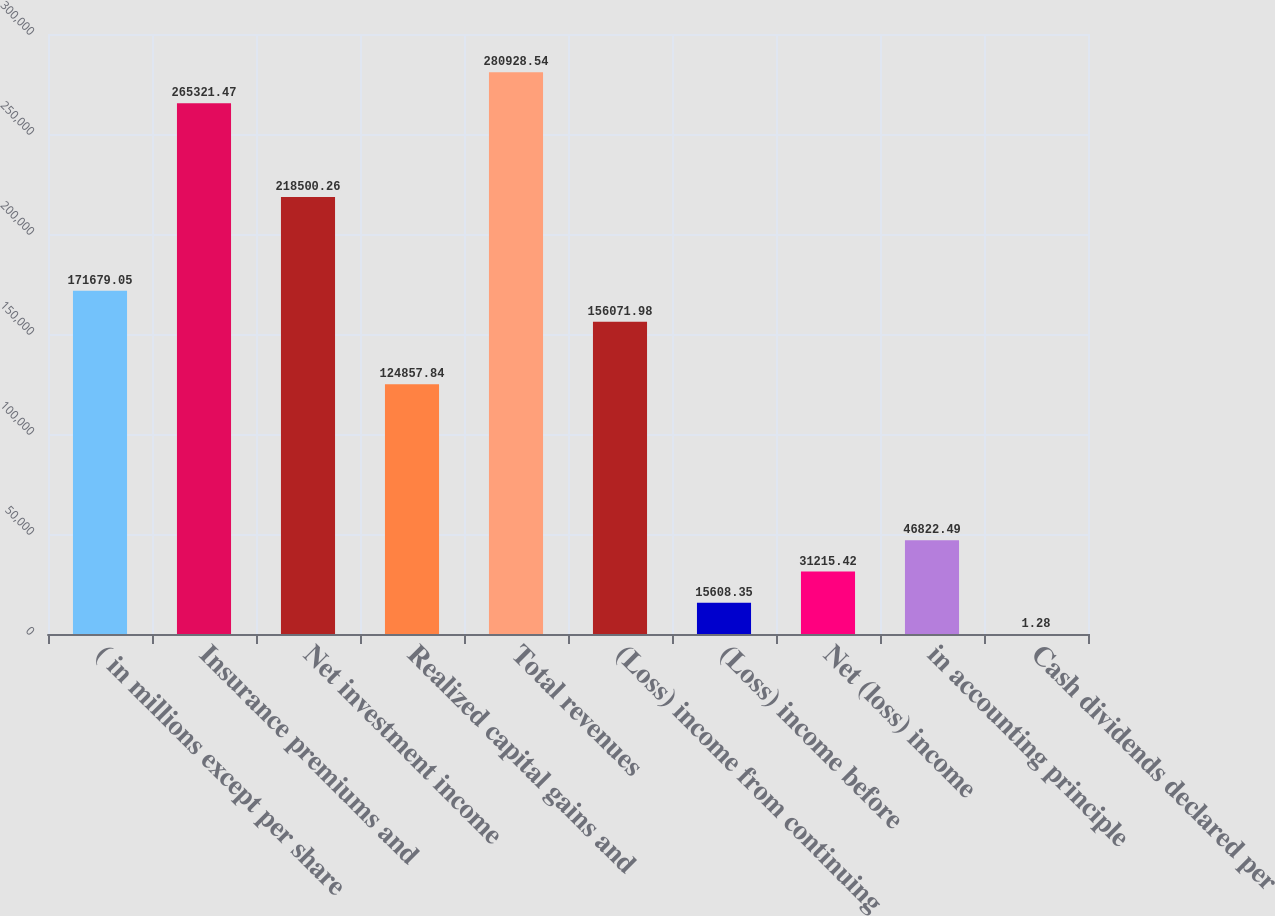Convert chart to OTSL. <chart><loc_0><loc_0><loc_500><loc_500><bar_chart><fcel>( in millions except per share<fcel>Insurance premiums and<fcel>Net investment income<fcel>Realized capital gains and<fcel>Total revenues<fcel>(Loss) income from continuing<fcel>(Loss) income before<fcel>Net (loss) income<fcel>in accounting principle<fcel>Cash dividends declared per<nl><fcel>171679<fcel>265321<fcel>218500<fcel>124858<fcel>280929<fcel>156072<fcel>15608.4<fcel>31215.4<fcel>46822.5<fcel>1.28<nl></chart> 